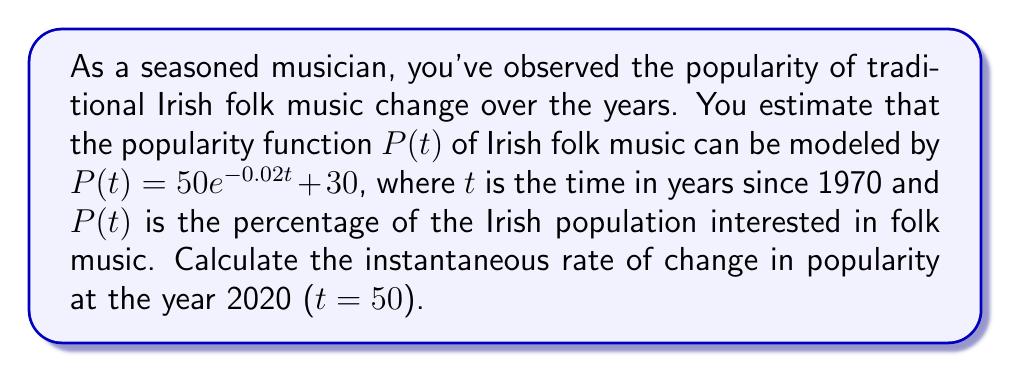What is the answer to this math problem? To find the instantaneous rate of change, we need to calculate the derivative of the popularity function $P(t)$ and evaluate it at $t = 50$.

Step 1: Find the derivative of $P(t)$.
$$\frac{d}{dt}P(t) = \frac{d}{dt}(50e^{-0.02t} + 30)$$
$$P'(t) = 50 \cdot (-0.02)e^{-0.02t} + 0$$
$$P'(t) = -e^{-0.02t}$$

Step 2: Evaluate $P'(t)$ at $t = 50$.
$$P'(50) = -e^{-0.02(50)}$$
$$P'(50) = -e^{-1}$$

Step 3: Calculate the value.
$$P'(50) \approx -0.3679$$

The negative value indicates that the popularity is decreasing. The rate of change is approximately -0.3679 percentage points per year in 2020.
Answer: $-0.3679$ percentage points per year 